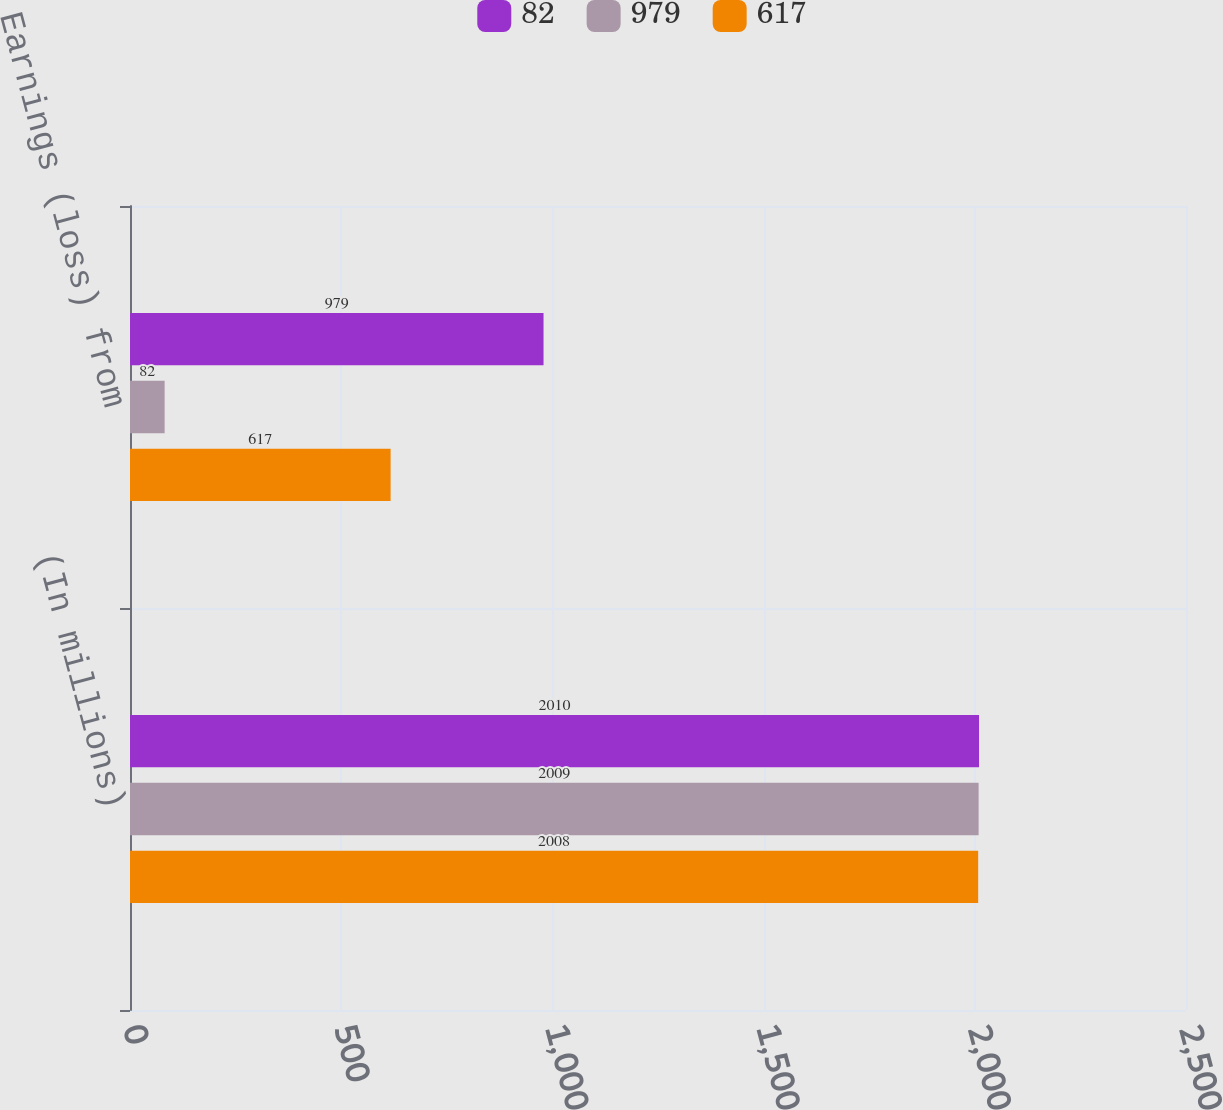Convert chart to OTSL. <chart><loc_0><loc_0><loc_500><loc_500><stacked_bar_chart><ecel><fcel>(In millions)<fcel>Earnings (loss) from<nl><fcel>82<fcel>2010<fcel>979<nl><fcel>979<fcel>2009<fcel>82<nl><fcel>617<fcel>2008<fcel>617<nl></chart> 